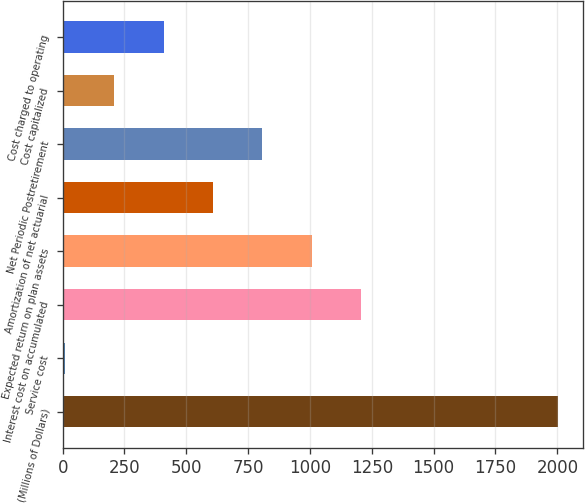Convert chart. <chart><loc_0><loc_0><loc_500><loc_500><bar_chart><fcel>(Millions of Dollars)<fcel>Service cost<fcel>Interest cost on accumulated<fcel>Expected return on plan assets<fcel>Amortization of net actuarial<fcel>Net Periodic Postretirement<fcel>Cost capitalized<fcel>Cost charged to operating<nl><fcel>2003<fcel>10<fcel>1205.8<fcel>1006.5<fcel>607.9<fcel>807.2<fcel>209.3<fcel>408.6<nl></chart> 